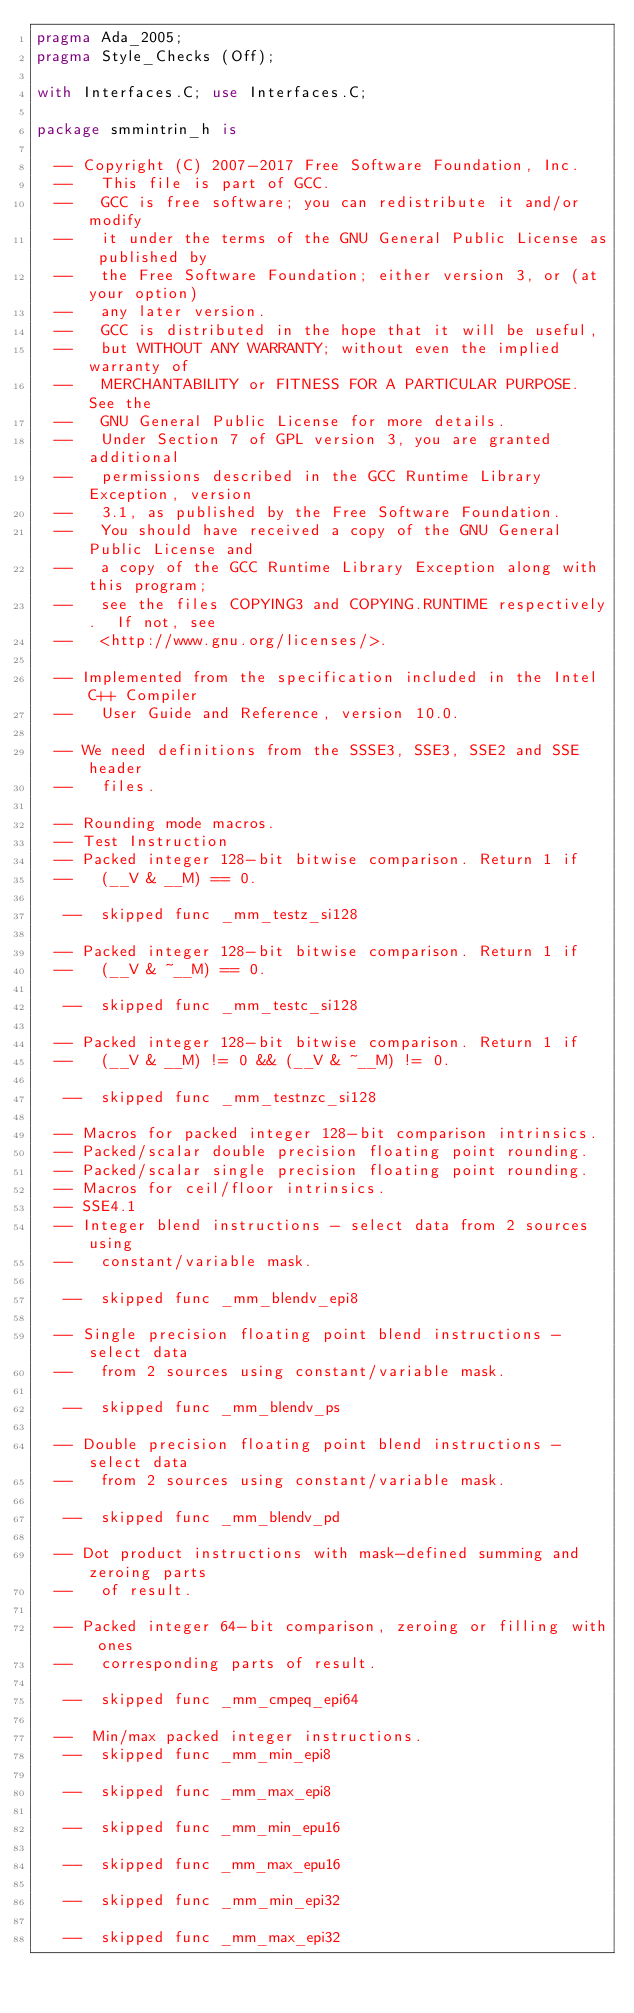<code> <loc_0><loc_0><loc_500><loc_500><_Ada_>pragma Ada_2005;
pragma Style_Checks (Off);

with Interfaces.C; use Interfaces.C;

package smmintrin_h is

  -- Copyright (C) 2007-2017 Free Software Foundation, Inc.
  --   This file is part of GCC.
  --   GCC is free software; you can redistribute it and/or modify
  --   it under the terms of the GNU General Public License as published by
  --   the Free Software Foundation; either version 3, or (at your option)
  --   any later version.
  --   GCC is distributed in the hope that it will be useful,
  --   but WITHOUT ANY WARRANTY; without even the implied warranty of
  --   MERCHANTABILITY or FITNESS FOR A PARTICULAR PURPOSE.  See the
  --   GNU General Public License for more details.
  --   Under Section 7 of GPL version 3, you are granted additional
  --   permissions described in the GCC Runtime Library Exception, version
  --   3.1, as published by the Free Software Foundation.
  --   You should have received a copy of the GNU General Public License and
  --   a copy of the GCC Runtime Library Exception along with this program;
  --   see the files COPYING3 and COPYING.RUNTIME respectively.  If not, see
  --   <http://www.gnu.org/licenses/>.   

  -- Implemented from the specification included in the Intel C++ Compiler
  --   User Guide and Reference, version 10.0.   

  -- We need definitions from the SSSE3, SSE3, SSE2 and SSE header
  --   files.   

  -- Rounding mode macros.  
  -- Test Instruction  
  -- Packed integer 128-bit bitwise comparison. Return 1 if
  --   (__V & __M) == 0.   

   --  skipped func _mm_testz_si128

  -- Packed integer 128-bit bitwise comparison. Return 1 if
  --   (__V & ~__M) == 0.   

   --  skipped func _mm_testc_si128

  -- Packed integer 128-bit bitwise comparison. Return 1 if
  --   (__V & __M) != 0 && (__V & ~__M) != 0.   

   --  skipped func _mm_testnzc_si128

  -- Macros for packed integer 128-bit comparison intrinsics.   
  -- Packed/scalar double precision floating point rounding.   
  -- Packed/scalar single precision floating point rounding.   
  -- Macros for ceil/floor intrinsics.   
  -- SSE4.1  
  -- Integer blend instructions - select data from 2 sources using
  --   constant/variable mask.   

   --  skipped func _mm_blendv_epi8

  -- Single precision floating point blend instructions - select data
  --   from 2 sources using constant/variable mask.   

   --  skipped func _mm_blendv_ps

  -- Double precision floating point blend instructions - select data
  --   from 2 sources using constant/variable mask.   

   --  skipped func _mm_blendv_pd

  -- Dot product instructions with mask-defined summing and zeroing parts
  --   of result.   

  -- Packed integer 64-bit comparison, zeroing or filling with ones
  --   corresponding parts of result.   

   --  skipped func _mm_cmpeq_epi64

  --  Min/max packed integer instructions.   
   --  skipped func _mm_min_epi8

   --  skipped func _mm_max_epi8

   --  skipped func _mm_min_epu16

   --  skipped func _mm_max_epu16

   --  skipped func _mm_min_epi32

   --  skipped func _mm_max_epi32
</code> 